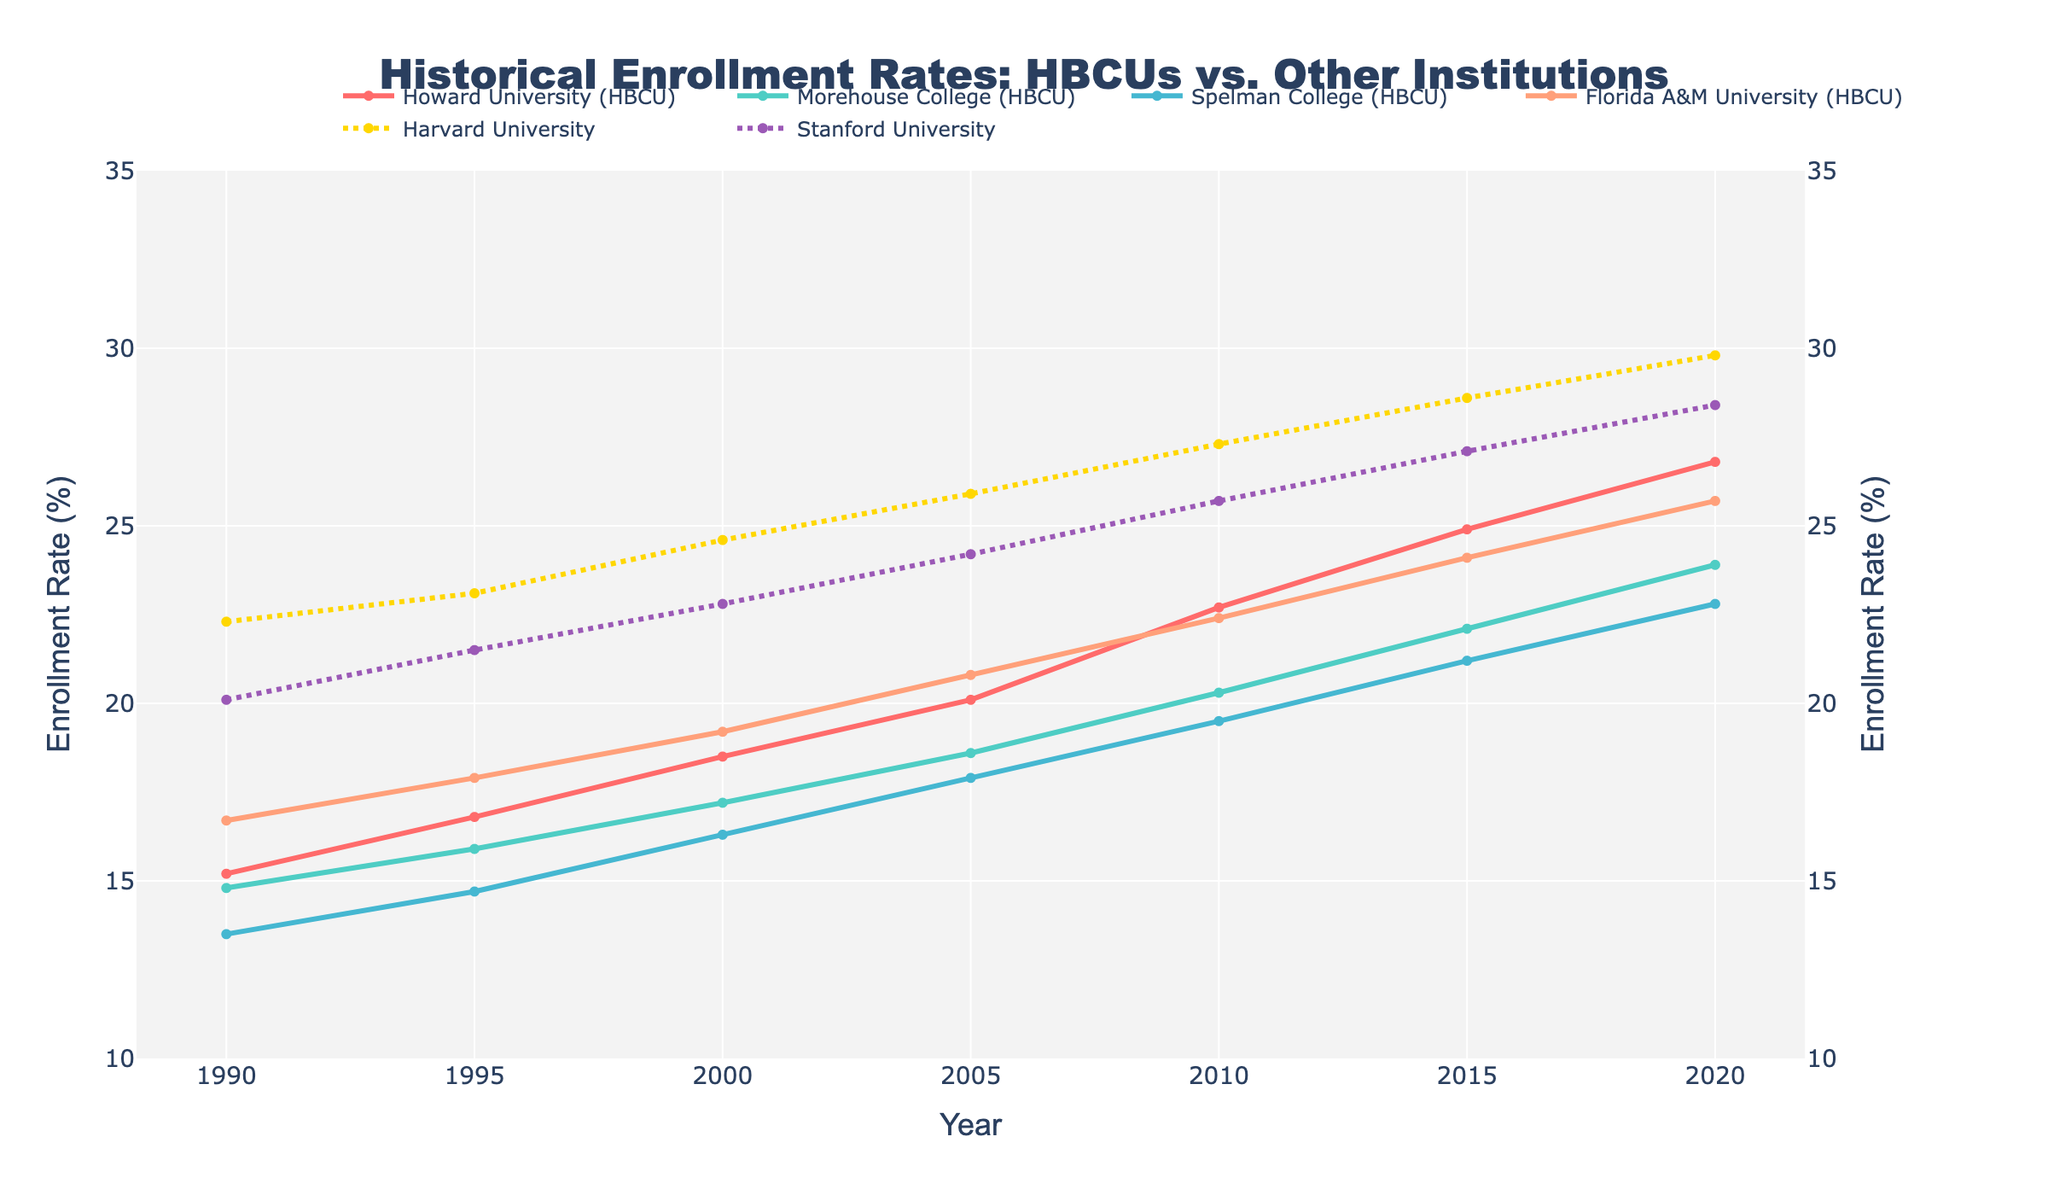What's the trend in enrollment rates at Howard University from 1990 to 2020? Observing the line corresponding to Howard University, we see a consistent upward trajectory over the years, moving from 15.2% in 1990 to 26.8% in 2020. This indicates a continuous increase in enrollment rates.
Answer: Increasing How does the 2020 enrollment rate at Harvard University compare to that at Morehouse College? In 2020, the enrollment rate at Harvard University is 29.8%, while at Morehouse College it is 23.9%. By comparison, Harvard University's enrollment rate is higher.
Answer: Harvard University's rate is higher Which institution had the highest increase in enrollment rates between 1990 and 2020? Calculate the increase for each institution: Howard (+11.6), Morehouse (+9.1), Spelman (+9.3), Florida A&M (+9.0), Harvard (+7.5), Stanford (+8.3). Howard University shows the largest increase of 11.6%.
Answer: Howard University What is the average enrollment rate at Spelman College and Stanford University in 2010? Calculate individually for Spelman (19.5%) and Stanford (25.7%), then find the average: (19.5 + 25.7) / 2 = 22.6%.
Answer: 22.6% By how much did Stanford University's enrollment rate grow from 1995 to 2020? Look at the data points for Stanford in 1995 (21.5%) and in 2020 (28.4%), then find the difference: 28.4 - 21.5 = 6.9%.
Answer: 6.9% Which HBCU had the lowest enrollment rate in 2000 and what was the rate? In 2000, look at the HBCU rates: Howard (18.5%), Morehouse (17.2%), Spelman (16.3%), Florida A&M (19.2%). The lowest rate is at Spelman College, 16.3%.
Answer: Spelman College, 16.3% Which institutions had a steady enrolment rate increase every 5 years? Observing the trend lines: Howard University, Morehouse College, Spelman College, Florida A&M, Harvard University, and Stanford University all show consistent incremental increases over the years.
Answer: All listed institutions Is there any year when the enrollment rates at Howard University and Morehouse College were the same? Checking each year's data, there is no year when the enrollment rates for Howard University and Morehouse College are the same.
Answer: No What is the difference in enrollment rates between Spelman College and Florida A&M University in 2015? Subtract the rate for Spelman (21.2%) from the rate for Florida A&M (24.1%): 24.1 - 21.2 = 2.9%.
Answer: 2.9% Between 1995 and 2005, which institution had the highest percentage point increase in enrollment rate? Calculate the increase for each institution: Howard (+3.3), Morehouse (+2.7), Spelman (+3.2), Florida A&M (+2.9), Harvard (+2.8), Stanford (+2.7). Howard University had the highest increase (16.8% to 20.1%).
Answer: Howard University 